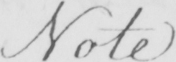Please transcribe the handwritten text in this image. Note 